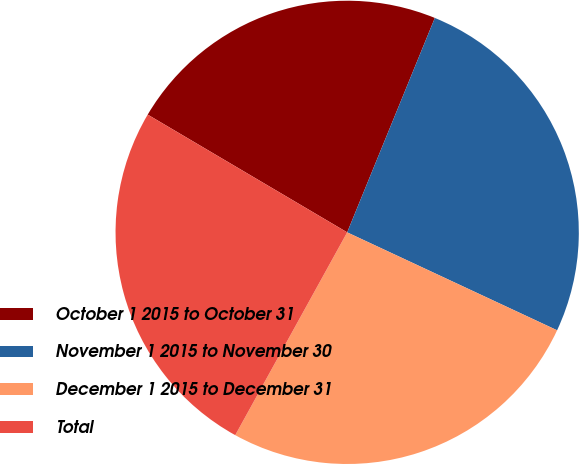Convert chart to OTSL. <chart><loc_0><loc_0><loc_500><loc_500><pie_chart><fcel>October 1 2015 to October 31<fcel>November 1 2015 to November 30<fcel>December 1 2015 to December 31<fcel>Total<nl><fcel>22.69%<fcel>25.77%<fcel>26.08%<fcel>25.46%<nl></chart> 